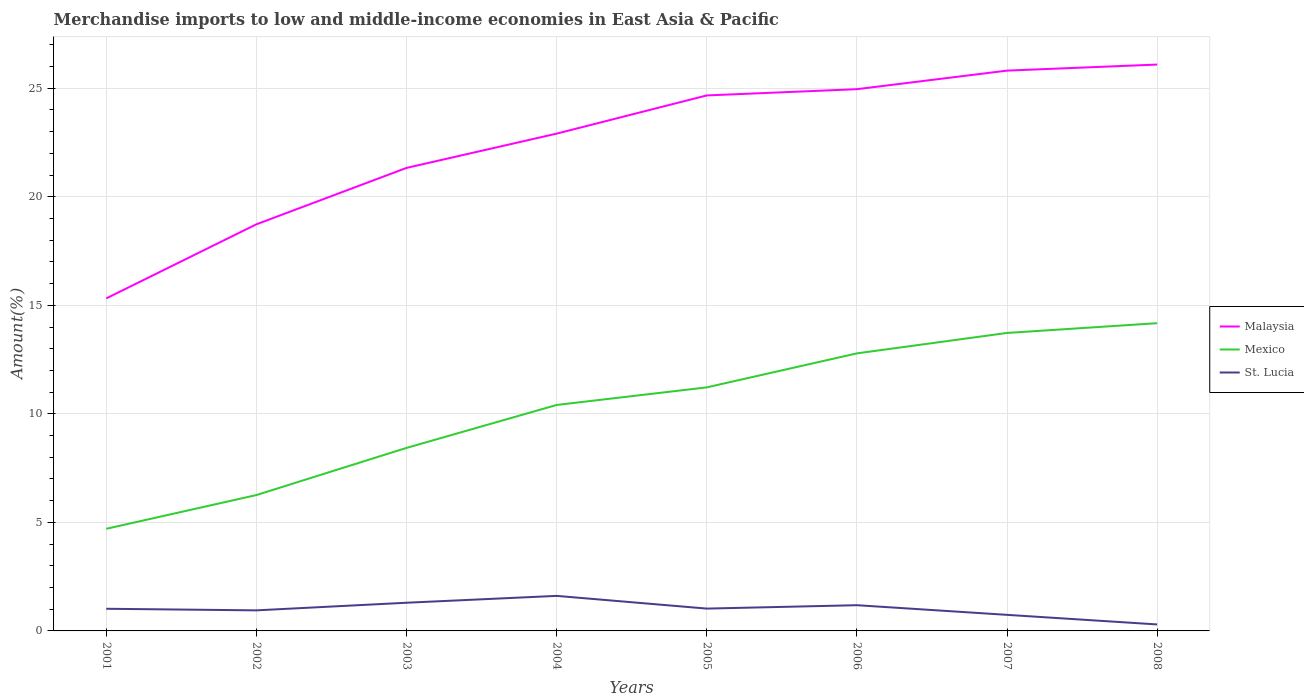How many different coloured lines are there?
Offer a very short reply. 3. Across all years, what is the maximum percentage of amount earned from merchandise imports in Mexico?
Ensure brevity in your answer.  4.71. In which year was the percentage of amount earned from merchandise imports in St. Lucia maximum?
Offer a terse response. 2008. What is the total percentage of amount earned from merchandise imports in Mexico in the graph?
Give a very brief answer. -3.73. What is the difference between the highest and the second highest percentage of amount earned from merchandise imports in St. Lucia?
Provide a succinct answer. 1.32. How many lines are there?
Offer a very short reply. 3. What is the difference between two consecutive major ticks on the Y-axis?
Your answer should be very brief. 5. Are the values on the major ticks of Y-axis written in scientific E-notation?
Give a very brief answer. No. Does the graph contain grids?
Make the answer very short. Yes. Where does the legend appear in the graph?
Make the answer very short. Center right. How many legend labels are there?
Ensure brevity in your answer.  3. How are the legend labels stacked?
Ensure brevity in your answer.  Vertical. What is the title of the graph?
Keep it short and to the point. Merchandise imports to low and middle-income economies in East Asia & Pacific. What is the label or title of the X-axis?
Provide a succinct answer. Years. What is the label or title of the Y-axis?
Provide a short and direct response. Amount(%). What is the Amount(%) of Malaysia in 2001?
Your answer should be compact. 15.32. What is the Amount(%) of Mexico in 2001?
Your response must be concise. 4.71. What is the Amount(%) of St. Lucia in 2001?
Your answer should be very brief. 1.02. What is the Amount(%) in Malaysia in 2002?
Your answer should be compact. 18.73. What is the Amount(%) in Mexico in 2002?
Provide a succinct answer. 6.26. What is the Amount(%) in St. Lucia in 2002?
Provide a succinct answer. 0.95. What is the Amount(%) of Malaysia in 2003?
Your response must be concise. 21.33. What is the Amount(%) in Mexico in 2003?
Ensure brevity in your answer.  8.43. What is the Amount(%) in St. Lucia in 2003?
Make the answer very short. 1.3. What is the Amount(%) of Malaysia in 2004?
Make the answer very short. 22.91. What is the Amount(%) in Mexico in 2004?
Your response must be concise. 10.41. What is the Amount(%) of St. Lucia in 2004?
Your response must be concise. 1.61. What is the Amount(%) of Malaysia in 2005?
Give a very brief answer. 24.67. What is the Amount(%) in Mexico in 2005?
Your answer should be compact. 11.22. What is the Amount(%) of St. Lucia in 2005?
Ensure brevity in your answer.  1.03. What is the Amount(%) in Malaysia in 2006?
Offer a very short reply. 24.96. What is the Amount(%) of Mexico in 2006?
Ensure brevity in your answer.  12.79. What is the Amount(%) of St. Lucia in 2006?
Provide a short and direct response. 1.18. What is the Amount(%) in Malaysia in 2007?
Your answer should be very brief. 25.81. What is the Amount(%) in Mexico in 2007?
Your response must be concise. 13.73. What is the Amount(%) in St. Lucia in 2007?
Keep it short and to the point. 0.74. What is the Amount(%) in Malaysia in 2008?
Your answer should be very brief. 26.09. What is the Amount(%) of Mexico in 2008?
Provide a succinct answer. 14.18. What is the Amount(%) of St. Lucia in 2008?
Keep it short and to the point. 0.3. Across all years, what is the maximum Amount(%) of Malaysia?
Give a very brief answer. 26.09. Across all years, what is the maximum Amount(%) of Mexico?
Ensure brevity in your answer.  14.18. Across all years, what is the maximum Amount(%) in St. Lucia?
Make the answer very short. 1.61. Across all years, what is the minimum Amount(%) of Malaysia?
Offer a terse response. 15.32. Across all years, what is the minimum Amount(%) of Mexico?
Offer a very short reply. 4.71. Across all years, what is the minimum Amount(%) in St. Lucia?
Offer a terse response. 0.3. What is the total Amount(%) in Malaysia in the graph?
Your answer should be compact. 179.83. What is the total Amount(%) in Mexico in the graph?
Your response must be concise. 81.72. What is the total Amount(%) of St. Lucia in the graph?
Give a very brief answer. 8.13. What is the difference between the Amount(%) of Malaysia in 2001 and that in 2002?
Make the answer very short. -3.41. What is the difference between the Amount(%) in Mexico in 2001 and that in 2002?
Provide a short and direct response. -1.55. What is the difference between the Amount(%) in St. Lucia in 2001 and that in 2002?
Provide a succinct answer. 0.07. What is the difference between the Amount(%) of Malaysia in 2001 and that in 2003?
Offer a very short reply. -6.01. What is the difference between the Amount(%) in Mexico in 2001 and that in 2003?
Keep it short and to the point. -3.73. What is the difference between the Amount(%) in St. Lucia in 2001 and that in 2003?
Your answer should be compact. -0.28. What is the difference between the Amount(%) in Malaysia in 2001 and that in 2004?
Your answer should be compact. -7.59. What is the difference between the Amount(%) of Mexico in 2001 and that in 2004?
Keep it short and to the point. -5.7. What is the difference between the Amount(%) of St. Lucia in 2001 and that in 2004?
Provide a succinct answer. -0.59. What is the difference between the Amount(%) of Malaysia in 2001 and that in 2005?
Keep it short and to the point. -9.35. What is the difference between the Amount(%) in Mexico in 2001 and that in 2005?
Ensure brevity in your answer.  -6.51. What is the difference between the Amount(%) in St. Lucia in 2001 and that in 2005?
Make the answer very short. -0.01. What is the difference between the Amount(%) of Malaysia in 2001 and that in 2006?
Give a very brief answer. -9.64. What is the difference between the Amount(%) in Mexico in 2001 and that in 2006?
Make the answer very short. -8.08. What is the difference between the Amount(%) in St. Lucia in 2001 and that in 2006?
Keep it short and to the point. -0.16. What is the difference between the Amount(%) of Malaysia in 2001 and that in 2007?
Provide a short and direct response. -10.49. What is the difference between the Amount(%) of Mexico in 2001 and that in 2007?
Offer a very short reply. -9.02. What is the difference between the Amount(%) in St. Lucia in 2001 and that in 2007?
Provide a succinct answer. 0.28. What is the difference between the Amount(%) in Malaysia in 2001 and that in 2008?
Your answer should be compact. -10.77. What is the difference between the Amount(%) of Mexico in 2001 and that in 2008?
Give a very brief answer. -9.47. What is the difference between the Amount(%) in St. Lucia in 2001 and that in 2008?
Keep it short and to the point. 0.72. What is the difference between the Amount(%) in Malaysia in 2002 and that in 2003?
Keep it short and to the point. -2.6. What is the difference between the Amount(%) of Mexico in 2002 and that in 2003?
Offer a terse response. -2.17. What is the difference between the Amount(%) in St. Lucia in 2002 and that in 2003?
Provide a short and direct response. -0.35. What is the difference between the Amount(%) of Malaysia in 2002 and that in 2004?
Offer a terse response. -4.18. What is the difference between the Amount(%) in Mexico in 2002 and that in 2004?
Your answer should be compact. -4.15. What is the difference between the Amount(%) of St. Lucia in 2002 and that in 2004?
Your answer should be compact. -0.67. What is the difference between the Amount(%) of Malaysia in 2002 and that in 2005?
Offer a terse response. -5.94. What is the difference between the Amount(%) in Mexico in 2002 and that in 2005?
Your response must be concise. -4.96. What is the difference between the Amount(%) in St. Lucia in 2002 and that in 2005?
Offer a terse response. -0.08. What is the difference between the Amount(%) of Malaysia in 2002 and that in 2006?
Your answer should be compact. -6.23. What is the difference between the Amount(%) of Mexico in 2002 and that in 2006?
Your answer should be compact. -6.53. What is the difference between the Amount(%) of St. Lucia in 2002 and that in 2006?
Keep it short and to the point. -0.24. What is the difference between the Amount(%) in Malaysia in 2002 and that in 2007?
Provide a succinct answer. -7.08. What is the difference between the Amount(%) in Mexico in 2002 and that in 2007?
Give a very brief answer. -7.47. What is the difference between the Amount(%) in St. Lucia in 2002 and that in 2007?
Provide a short and direct response. 0.21. What is the difference between the Amount(%) of Malaysia in 2002 and that in 2008?
Your answer should be compact. -7.36. What is the difference between the Amount(%) of Mexico in 2002 and that in 2008?
Keep it short and to the point. -7.92. What is the difference between the Amount(%) in St. Lucia in 2002 and that in 2008?
Keep it short and to the point. 0.65. What is the difference between the Amount(%) in Malaysia in 2003 and that in 2004?
Provide a succinct answer. -1.58. What is the difference between the Amount(%) in Mexico in 2003 and that in 2004?
Your answer should be very brief. -1.98. What is the difference between the Amount(%) of St. Lucia in 2003 and that in 2004?
Your answer should be compact. -0.32. What is the difference between the Amount(%) in Malaysia in 2003 and that in 2005?
Provide a succinct answer. -3.34. What is the difference between the Amount(%) of Mexico in 2003 and that in 2005?
Give a very brief answer. -2.79. What is the difference between the Amount(%) in St. Lucia in 2003 and that in 2005?
Offer a terse response. 0.27. What is the difference between the Amount(%) of Malaysia in 2003 and that in 2006?
Ensure brevity in your answer.  -3.63. What is the difference between the Amount(%) in Mexico in 2003 and that in 2006?
Your answer should be very brief. -4.35. What is the difference between the Amount(%) in St. Lucia in 2003 and that in 2006?
Ensure brevity in your answer.  0.11. What is the difference between the Amount(%) of Malaysia in 2003 and that in 2007?
Your response must be concise. -4.48. What is the difference between the Amount(%) in Mexico in 2003 and that in 2007?
Provide a short and direct response. -5.3. What is the difference between the Amount(%) in St. Lucia in 2003 and that in 2007?
Your response must be concise. 0.56. What is the difference between the Amount(%) of Malaysia in 2003 and that in 2008?
Provide a succinct answer. -4.76. What is the difference between the Amount(%) of Mexico in 2003 and that in 2008?
Your answer should be compact. -5.75. What is the difference between the Amount(%) of St. Lucia in 2003 and that in 2008?
Your answer should be very brief. 1. What is the difference between the Amount(%) of Malaysia in 2004 and that in 2005?
Keep it short and to the point. -1.76. What is the difference between the Amount(%) in Mexico in 2004 and that in 2005?
Make the answer very short. -0.81. What is the difference between the Amount(%) in St. Lucia in 2004 and that in 2005?
Offer a terse response. 0.59. What is the difference between the Amount(%) in Malaysia in 2004 and that in 2006?
Give a very brief answer. -2.05. What is the difference between the Amount(%) of Mexico in 2004 and that in 2006?
Offer a terse response. -2.38. What is the difference between the Amount(%) of St. Lucia in 2004 and that in 2006?
Keep it short and to the point. 0.43. What is the difference between the Amount(%) of Malaysia in 2004 and that in 2007?
Make the answer very short. -2.9. What is the difference between the Amount(%) in Mexico in 2004 and that in 2007?
Keep it short and to the point. -3.32. What is the difference between the Amount(%) of St. Lucia in 2004 and that in 2007?
Your answer should be very brief. 0.87. What is the difference between the Amount(%) of Malaysia in 2004 and that in 2008?
Make the answer very short. -3.18. What is the difference between the Amount(%) of Mexico in 2004 and that in 2008?
Offer a very short reply. -3.77. What is the difference between the Amount(%) of St. Lucia in 2004 and that in 2008?
Make the answer very short. 1.32. What is the difference between the Amount(%) of Malaysia in 2005 and that in 2006?
Your answer should be very brief. -0.29. What is the difference between the Amount(%) in Mexico in 2005 and that in 2006?
Ensure brevity in your answer.  -1.57. What is the difference between the Amount(%) of St. Lucia in 2005 and that in 2006?
Your response must be concise. -0.16. What is the difference between the Amount(%) of Malaysia in 2005 and that in 2007?
Offer a terse response. -1.14. What is the difference between the Amount(%) in Mexico in 2005 and that in 2007?
Offer a terse response. -2.51. What is the difference between the Amount(%) of St. Lucia in 2005 and that in 2007?
Make the answer very short. 0.29. What is the difference between the Amount(%) of Malaysia in 2005 and that in 2008?
Ensure brevity in your answer.  -1.42. What is the difference between the Amount(%) in Mexico in 2005 and that in 2008?
Make the answer very short. -2.96. What is the difference between the Amount(%) in St. Lucia in 2005 and that in 2008?
Your answer should be very brief. 0.73. What is the difference between the Amount(%) in Malaysia in 2006 and that in 2007?
Offer a terse response. -0.86. What is the difference between the Amount(%) in Mexico in 2006 and that in 2007?
Offer a terse response. -0.94. What is the difference between the Amount(%) of St. Lucia in 2006 and that in 2007?
Make the answer very short. 0.44. What is the difference between the Amount(%) of Malaysia in 2006 and that in 2008?
Your answer should be compact. -1.13. What is the difference between the Amount(%) in Mexico in 2006 and that in 2008?
Offer a terse response. -1.39. What is the difference between the Amount(%) in St. Lucia in 2006 and that in 2008?
Ensure brevity in your answer.  0.89. What is the difference between the Amount(%) in Malaysia in 2007 and that in 2008?
Give a very brief answer. -0.28. What is the difference between the Amount(%) in Mexico in 2007 and that in 2008?
Your response must be concise. -0.45. What is the difference between the Amount(%) in St. Lucia in 2007 and that in 2008?
Offer a very short reply. 0.44. What is the difference between the Amount(%) of Malaysia in 2001 and the Amount(%) of Mexico in 2002?
Give a very brief answer. 9.06. What is the difference between the Amount(%) in Malaysia in 2001 and the Amount(%) in St. Lucia in 2002?
Keep it short and to the point. 14.37. What is the difference between the Amount(%) in Mexico in 2001 and the Amount(%) in St. Lucia in 2002?
Provide a short and direct response. 3.76. What is the difference between the Amount(%) of Malaysia in 2001 and the Amount(%) of Mexico in 2003?
Your response must be concise. 6.89. What is the difference between the Amount(%) of Malaysia in 2001 and the Amount(%) of St. Lucia in 2003?
Give a very brief answer. 14.02. What is the difference between the Amount(%) in Mexico in 2001 and the Amount(%) in St. Lucia in 2003?
Provide a short and direct response. 3.41. What is the difference between the Amount(%) in Malaysia in 2001 and the Amount(%) in Mexico in 2004?
Provide a succinct answer. 4.91. What is the difference between the Amount(%) of Malaysia in 2001 and the Amount(%) of St. Lucia in 2004?
Ensure brevity in your answer.  13.71. What is the difference between the Amount(%) of Mexico in 2001 and the Amount(%) of St. Lucia in 2004?
Ensure brevity in your answer.  3.09. What is the difference between the Amount(%) of Malaysia in 2001 and the Amount(%) of Mexico in 2005?
Provide a succinct answer. 4.1. What is the difference between the Amount(%) of Malaysia in 2001 and the Amount(%) of St. Lucia in 2005?
Provide a succinct answer. 14.29. What is the difference between the Amount(%) in Mexico in 2001 and the Amount(%) in St. Lucia in 2005?
Your answer should be very brief. 3.68. What is the difference between the Amount(%) of Malaysia in 2001 and the Amount(%) of Mexico in 2006?
Keep it short and to the point. 2.53. What is the difference between the Amount(%) in Malaysia in 2001 and the Amount(%) in St. Lucia in 2006?
Provide a short and direct response. 14.14. What is the difference between the Amount(%) of Mexico in 2001 and the Amount(%) of St. Lucia in 2006?
Make the answer very short. 3.52. What is the difference between the Amount(%) of Malaysia in 2001 and the Amount(%) of Mexico in 2007?
Your response must be concise. 1.59. What is the difference between the Amount(%) in Malaysia in 2001 and the Amount(%) in St. Lucia in 2007?
Offer a very short reply. 14.58. What is the difference between the Amount(%) in Mexico in 2001 and the Amount(%) in St. Lucia in 2007?
Provide a short and direct response. 3.97. What is the difference between the Amount(%) of Malaysia in 2001 and the Amount(%) of Mexico in 2008?
Make the answer very short. 1.14. What is the difference between the Amount(%) in Malaysia in 2001 and the Amount(%) in St. Lucia in 2008?
Your answer should be very brief. 15.02. What is the difference between the Amount(%) of Mexico in 2001 and the Amount(%) of St. Lucia in 2008?
Offer a very short reply. 4.41. What is the difference between the Amount(%) in Malaysia in 2002 and the Amount(%) in Mexico in 2003?
Your answer should be compact. 10.3. What is the difference between the Amount(%) of Malaysia in 2002 and the Amount(%) of St. Lucia in 2003?
Your response must be concise. 17.43. What is the difference between the Amount(%) of Mexico in 2002 and the Amount(%) of St. Lucia in 2003?
Give a very brief answer. 4.96. What is the difference between the Amount(%) in Malaysia in 2002 and the Amount(%) in Mexico in 2004?
Ensure brevity in your answer.  8.32. What is the difference between the Amount(%) of Malaysia in 2002 and the Amount(%) of St. Lucia in 2004?
Ensure brevity in your answer.  17.12. What is the difference between the Amount(%) of Mexico in 2002 and the Amount(%) of St. Lucia in 2004?
Your answer should be very brief. 4.64. What is the difference between the Amount(%) in Malaysia in 2002 and the Amount(%) in Mexico in 2005?
Your response must be concise. 7.51. What is the difference between the Amount(%) of Malaysia in 2002 and the Amount(%) of St. Lucia in 2005?
Your answer should be compact. 17.7. What is the difference between the Amount(%) in Mexico in 2002 and the Amount(%) in St. Lucia in 2005?
Offer a terse response. 5.23. What is the difference between the Amount(%) of Malaysia in 2002 and the Amount(%) of Mexico in 2006?
Provide a succinct answer. 5.95. What is the difference between the Amount(%) of Malaysia in 2002 and the Amount(%) of St. Lucia in 2006?
Make the answer very short. 17.55. What is the difference between the Amount(%) of Mexico in 2002 and the Amount(%) of St. Lucia in 2006?
Keep it short and to the point. 5.07. What is the difference between the Amount(%) in Malaysia in 2002 and the Amount(%) in Mexico in 2007?
Your answer should be very brief. 5. What is the difference between the Amount(%) of Malaysia in 2002 and the Amount(%) of St. Lucia in 2007?
Provide a succinct answer. 17.99. What is the difference between the Amount(%) of Mexico in 2002 and the Amount(%) of St. Lucia in 2007?
Your answer should be very brief. 5.52. What is the difference between the Amount(%) of Malaysia in 2002 and the Amount(%) of Mexico in 2008?
Make the answer very short. 4.56. What is the difference between the Amount(%) in Malaysia in 2002 and the Amount(%) in St. Lucia in 2008?
Ensure brevity in your answer.  18.43. What is the difference between the Amount(%) in Mexico in 2002 and the Amount(%) in St. Lucia in 2008?
Ensure brevity in your answer.  5.96. What is the difference between the Amount(%) in Malaysia in 2003 and the Amount(%) in Mexico in 2004?
Provide a succinct answer. 10.92. What is the difference between the Amount(%) of Malaysia in 2003 and the Amount(%) of St. Lucia in 2004?
Provide a succinct answer. 19.72. What is the difference between the Amount(%) in Mexico in 2003 and the Amount(%) in St. Lucia in 2004?
Your answer should be compact. 6.82. What is the difference between the Amount(%) in Malaysia in 2003 and the Amount(%) in Mexico in 2005?
Offer a terse response. 10.11. What is the difference between the Amount(%) of Malaysia in 2003 and the Amount(%) of St. Lucia in 2005?
Ensure brevity in your answer.  20.3. What is the difference between the Amount(%) in Mexico in 2003 and the Amount(%) in St. Lucia in 2005?
Offer a terse response. 7.4. What is the difference between the Amount(%) of Malaysia in 2003 and the Amount(%) of Mexico in 2006?
Provide a succinct answer. 8.54. What is the difference between the Amount(%) of Malaysia in 2003 and the Amount(%) of St. Lucia in 2006?
Provide a succinct answer. 20.15. What is the difference between the Amount(%) in Mexico in 2003 and the Amount(%) in St. Lucia in 2006?
Offer a terse response. 7.25. What is the difference between the Amount(%) of Malaysia in 2003 and the Amount(%) of Mexico in 2007?
Provide a short and direct response. 7.6. What is the difference between the Amount(%) of Malaysia in 2003 and the Amount(%) of St. Lucia in 2007?
Provide a short and direct response. 20.59. What is the difference between the Amount(%) of Mexico in 2003 and the Amount(%) of St. Lucia in 2007?
Your answer should be compact. 7.69. What is the difference between the Amount(%) of Malaysia in 2003 and the Amount(%) of Mexico in 2008?
Offer a terse response. 7.15. What is the difference between the Amount(%) of Malaysia in 2003 and the Amount(%) of St. Lucia in 2008?
Provide a succinct answer. 21.03. What is the difference between the Amount(%) of Mexico in 2003 and the Amount(%) of St. Lucia in 2008?
Your answer should be compact. 8.13. What is the difference between the Amount(%) of Malaysia in 2004 and the Amount(%) of Mexico in 2005?
Ensure brevity in your answer.  11.69. What is the difference between the Amount(%) of Malaysia in 2004 and the Amount(%) of St. Lucia in 2005?
Provide a short and direct response. 21.88. What is the difference between the Amount(%) of Mexico in 2004 and the Amount(%) of St. Lucia in 2005?
Provide a short and direct response. 9.38. What is the difference between the Amount(%) in Malaysia in 2004 and the Amount(%) in Mexico in 2006?
Provide a short and direct response. 10.12. What is the difference between the Amount(%) in Malaysia in 2004 and the Amount(%) in St. Lucia in 2006?
Provide a succinct answer. 21.73. What is the difference between the Amount(%) of Mexico in 2004 and the Amount(%) of St. Lucia in 2006?
Provide a succinct answer. 9.23. What is the difference between the Amount(%) of Malaysia in 2004 and the Amount(%) of Mexico in 2007?
Offer a very short reply. 9.18. What is the difference between the Amount(%) of Malaysia in 2004 and the Amount(%) of St. Lucia in 2007?
Ensure brevity in your answer.  22.17. What is the difference between the Amount(%) of Mexico in 2004 and the Amount(%) of St. Lucia in 2007?
Give a very brief answer. 9.67. What is the difference between the Amount(%) in Malaysia in 2004 and the Amount(%) in Mexico in 2008?
Your answer should be compact. 8.73. What is the difference between the Amount(%) in Malaysia in 2004 and the Amount(%) in St. Lucia in 2008?
Offer a very short reply. 22.61. What is the difference between the Amount(%) in Mexico in 2004 and the Amount(%) in St. Lucia in 2008?
Your answer should be compact. 10.11. What is the difference between the Amount(%) of Malaysia in 2005 and the Amount(%) of Mexico in 2006?
Offer a very short reply. 11.88. What is the difference between the Amount(%) in Malaysia in 2005 and the Amount(%) in St. Lucia in 2006?
Your answer should be compact. 23.49. What is the difference between the Amount(%) of Mexico in 2005 and the Amount(%) of St. Lucia in 2006?
Offer a terse response. 10.04. What is the difference between the Amount(%) of Malaysia in 2005 and the Amount(%) of Mexico in 2007?
Offer a terse response. 10.94. What is the difference between the Amount(%) of Malaysia in 2005 and the Amount(%) of St. Lucia in 2007?
Your answer should be compact. 23.93. What is the difference between the Amount(%) in Mexico in 2005 and the Amount(%) in St. Lucia in 2007?
Make the answer very short. 10.48. What is the difference between the Amount(%) of Malaysia in 2005 and the Amount(%) of Mexico in 2008?
Give a very brief answer. 10.49. What is the difference between the Amount(%) of Malaysia in 2005 and the Amount(%) of St. Lucia in 2008?
Give a very brief answer. 24.37. What is the difference between the Amount(%) of Mexico in 2005 and the Amount(%) of St. Lucia in 2008?
Provide a succinct answer. 10.92. What is the difference between the Amount(%) in Malaysia in 2006 and the Amount(%) in Mexico in 2007?
Give a very brief answer. 11.23. What is the difference between the Amount(%) in Malaysia in 2006 and the Amount(%) in St. Lucia in 2007?
Provide a succinct answer. 24.22. What is the difference between the Amount(%) in Mexico in 2006 and the Amount(%) in St. Lucia in 2007?
Your answer should be very brief. 12.05. What is the difference between the Amount(%) of Malaysia in 2006 and the Amount(%) of Mexico in 2008?
Offer a terse response. 10.78. What is the difference between the Amount(%) in Malaysia in 2006 and the Amount(%) in St. Lucia in 2008?
Your response must be concise. 24.66. What is the difference between the Amount(%) of Mexico in 2006 and the Amount(%) of St. Lucia in 2008?
Keep it short and to the point. 12.49. What is the difference between the Amount(%) of Malaysia in 2007 and the Amount(%) of Mexico in 2008?
Your answer should be compact. 11.64. What is the difference between the Amount(%) in Malaysia in 2007 and the Amount(%) in St. Lucia in 2008?
Offer a very short reply. 25.51. What is the difference between the Amount(%) in Mexico in 2007 and the Amount(%) in St. Lucia in 2008?
Give a very brief answer. 13.43. What is the average Amount(%) in Malaysia per year?
Provide a short and direct response. 22.48. What is the average Amount(%) in Mexico per year?
Give a very brief answer. 10.21. What is the average Amount(%) of St. Lucia per year?
Your response must be concise. 1.02. In the year 2001, what is the difference between the Amount(%) of Malaysia and Amount(%) of Mexico?
Give a very brief answer. 10.61. In the year 2001, what is the difference between the Amount(%) in Malaysia and Amount(%) in St. Lucia?
Your answer should be very brief. 14.3. In the year 2001, what is the difference between the Amount(%) of Mexico and Amount(%) of St. Lucia?
Keep it short and to the point. 3.68. In the year 2002, what is the difference between the Amount(%) of Malaysia and Amount(%) of Mexico?
Keep it short and to the point. 12.47. In the year 2002, what is the difference between the Amount(%) in Malaysia and Amount(%) in St. Lucia?
Provide a succinct answer. 17.79. In the year 2002, what is the difference between the Amount(%) of Mexico and Amount(%) of St. Lucia?
Your answer should be compact. 5.31. In the year 2003, what is the difference between the Amount(%) in Malaysia and Amount(%) in Mexico?
Offer a very short reply. 12.9. In the year 2003, what is the difference between the Amount(%) in Malaysia and Amount(%) in St. Lucia?
Give a very brief answer. 20.03. In the year 2003, what is the difference between the Amount(%) in Mexico and Amount(%) in St. Lucia?
Your answer should be compact. 7.13. In the year 2004, what is the difference between the Amount(%) of Malaysia and Amount(%) of Mexico?
Offer a very short reply. 12.5. In the year 2004, what is the difference between the Amount(%) in Malaysia and Amount(%) in St. Lucia?
Offer a very short reply. 21.3. In the year 2004, what is the difference between the Amount(%) in Mexico and Amount(%) in St. Lucia?
Provide a short and direct response. 8.8. In the year 2005, what is the difference between the Amount(%) in Malaysia and Amount(%) in Mexico?
Ensure brevity in your answer.  13.45. In the year 2005, what is the difference between the Amount(%) of Malaysia and Amount(%) of St. Lucia?
Ensure brevity in your answer.  23.64. In the year 2005, what is the difference between the Amount(%) in Mexico and Amount(%) in St. Lucia?
Make the answer very short. 10.19. In the year 2006, what is the difference between the Amount(%) in Malaysia and Amount(%) in Mexico?
Give a very brief answer. 12.17. In the year 2006, what is the difference between the Amount(%) in Malaysia and Amount(%) in St. Lucia?
Make the answer very short. 23.77. In the year 2006, what is the difference between the Amount(%) in Mexico and Amount(%) in St. Lucia?
Your answer should be very brief. 11.6. In the year 2007, what is the difference between the Amount(%) in Malaysia and Amount(%) in Mexico?
Offer a very short reply. 12.09. In the year 2007, what is the difference between the Amount(%) in Malaysia and Amount(%) in St. Lucia?
Provide a succinct answer. 25.07. In the year 2007, what is the difference between the Amount(%) of Mexico and Amount(%) of St. Lucia?
Keep it short and to the point. 12.99. In the year 2008, what is the difference between the Amount(%) in Malaysia and Amount(%) in Mexico?
Ensure brevity in your answer.  11.91. In the year 2008, what is the difference between the Amount(%) in Malaysia and Amount(%) in St. Lucia?
Ensure brevity in your answer.  25.79. In the year 2008, what is the difference between the Amount(%) of Mexico and Amount(%) of St. Lucia?
Offer a very short reply. 13.88. What is the ratio of the Amount(%) of Malaysia in 2001 to that in 2002?
Offer a terse response. 0.82. What is the ratio of the Amount(%) in Mexico in 2001 to that in 2002?
Give a very brief answer. 0.75. What is the ratio of the Amount(%) of St. Lucia in 2001 to that in 2002?
Make the answer very short. 1.08. What is the ratio of the Amount(%) of Malaysia in 2001 to that in 2003?
Your response must be concise. 0.72. What is the ratio of the Amount(%) in Mexico in 2001 to that in 2003?
Keep it short and to the point. 0.56. What is the ratio of the Amount(%) in St. Lucia in 2001 to that in 2003?
Make the answer very short. 0.79. What is the ratio of the Amount(%) of Malaysia in 2001 to that in 2004?
Provide a short and direct response. 0.67. What is the ratio of the Amount(%) of Mexico in 2001 to that in 2004?
Ensure brevity in your answer.  0.45. What is the ratio of the Amount(%) in St. Lucia in 2001 to that in 2004?
Provide a succinct answer. 0.63. What is the ratio of the Amount(%) in Malaysia in 2001 to that in 2005?
Provide a short and direct response. 0.62. What is the ratio of the Amount(%) of Mexico in 2001 to that in 2005?
Provide a succinct answer. 0.42. What is the ratio of the Amount(%) in St. Lucia in 2001 to that in 2005?
Keep it short and to the point. 0.99. What is the ratio of the Amount(%) of Malaysia in 2001 to that in 2006?
Your answer should be very brief. 0.61. What is the ratio of the Amount(%) of Mexico in 2001 to that in 2006?
Keep it short and to the point. 0.37. What is the ratio of the Amount(%) of St. Lucia in 2001 to that in 2006?
Offer a very short reply. 0.86. What is the ratio of the Amount(%) of Malaysia in 2001 to that in 2007?
Your answer should be very brief. 0.59. What is the ratio of the Amount(%) in Mexico in 2001 to that in 2007?
Give a very brief answer. 0.34. What is the ratio of the Amount(%) in St. Lucia in 2001 to that in 2007?
Offer a very short reply. 1.38. What is the ratio of the Amount(%) of Malaysia in 2001 to that in 2008?
Your answer should be compact. 0.59. What is the ratio of the Amount(%) in Mexico in 2001 to that in 2008?
Make the answer very short. 0.33. What is the ratio of the Amount(%) of St. Lucia in 2001 to that in 2008?
Provide a short and direct response. 3.41. What is the ratio of the Amount(%) of Malaysia in 2002 to that in 2003?
Make the answer very short. 0.88. What is the ratio of the Amount(%) of Mexico in 2002 to that in 2003?
Your answer should be very brief. 0.74. What is the ratio of the Amount(%) of St. Lucia in 2002 to that in 2003?
Ensure brevity in your answer.  0.73. What is the ratio of the Amount(%) of Malaysia in 2002 to that in 2004?
Offer a very short reply. 0.82. What is the ratio of the Amount(%) in Mexico in 2002 to that in 2004?
Your answer should be very brief. 0.6. What is the ratio of the Amount(%) of St. Lucia in 2002 to that in 2004?
Provide a short and direct response. 0.59. What is the ratio of the Amount(%) in Malaysia in 2002 to that in 2005?
Make the answer very short. 0.76. What is the ratio of the Amount(%) in Mexico in 2002 to that in 2005?
Keep it short and to the point. 0.56. What is the ratio of the Amount(%) of St. Lucia in 2002 to that in 2005?
Keep it short and to the point. 0.92. What is the ratio of the Amount(%) in Malaysia in 2002 to that in 2006?
Make the answer very short. 0.75. What is the ratio of the Amount(%) of Mexico in 2002 to that in 2006?
Keep it short and to the point. 0.49. What is the ratio of the Amount(%) of St. Lucia in 2002 to that in 2006?
Ensure brevity in your answer.  0.8. What is the ratio of the Amount(%) in Malaysia in 2002 to that in 2007?
Your response must be concise. 0.73. What is the ratio of the Amount(%) in Mexico in 2002 to that in 2007?
Your answer should be compact. 0.46. What is the ratio of the Amount(%) in St. Lucia in 2002 to that in 2007?
Your answer should be very brief. 1.28. What is the ratio of the Amount(%) of Malaysia in 2002 to that in 2008?
Give a very brief answer. 0.72. What is the ratio of the Amount(%) of Mexico in 2002 to that in 2008?
Provide a short and direct response. 0.44. What is the ratio of the Amount(%) of St. Lucia in 2002 to that in 2008?
Your answer should be compact. 3.17. What is the ratio of the Amount(%) in Mexico in 2003 to that in 2004?
Keep it short and to the point. 0.81. What is the ratio of the Amount(%) of St. Lucia in 2003 to that in 2004?
Your answer should be compact. 0.8. What is the ratio of the Amount(%) in Malaysia in 2003 to that in 2005?
Ensure brevity in your answer.  0.86. What is the ratio of the Amount(%) in Mexico in 2003 to that in 2005?
Provide a short and direct response. 0.75. What is the ratio of the Amount(%) in St. Lucia in 2003 to that in 2005?
Your answer should be very brief. 1.26. What is the ratio of the Amount(%) of Malaysia in 2003 to that in 2006?
Keep it short and to the point. 0.85. What is the ratio of the Amount(%) in Mexico in 2003 to that in 2006?
Your answer should be compact. 0.66. What is the ratio of the Amount(%) in St. Lucia in 2003 to that in 2006?
Offer a terse response. 1.1. What is the ratio of the Amount(%) in Malaysia in 2003 to that in 2007?
Make the answer very short. 0.83. What is the ratio of the Amount(%) of Mexico in 2003 to that in 2007?
Your response must be concise. 0.61. What is the ratio of the Amount(%) in St. Lucia in 2003 to that in 2007?
Keep it short and to the point. 1.75. What is the ratio of the Amount(%) in Malaysia in 2003 to that in 2008?
Give a very brief answer. 0.82. What is the ratio of the Amount(%) in Mexico in 2003 to that in 2008?
Make the answer very short. 0.59. What is the ratio of the Amount(%) in St. Lucia in 2003 to that in 2008?
Your answer should be compact. 4.34. What is the ratio of the Amount(%) of Malaysia in 2004 to that in 2005?
Offer a very short reply. 0.93. What is the ratio of the Amount(%) in Mexico in 2004 to that in 2005?
Your answer should be very brief. 0.93. What is the ratio of the Amount(%) of St. Lucia in 2004 to that in 2005?
Give a very brief answer. 1.57. What is the ratio of the Amount(%) in Malaysia in 2004 to that in 2006?
Keep it short and to the point. 0.92. What is the ratio of the Amount(%) of Mexico in 2004 to that in 2006?
Give a very brief answer. 0.81. What is the ratio of the Amount(%) of St. Lucia in 2004 to that in 2006?
Offer a terse response. 1.36. What is the ratio of the Amount(%) in Malaysia in 2004 to that in 2007?
Make the answer very short. 0.89. What is the ratio of the Amount(%) in Mexico in 2004 to that in 2007?
Offer a very short reply. 0.76. What is the ratio of the Amount(%) of St. Lucia in 2004 to that in 2007?
Keep it short and to the point. 2.18. What is the ratio of the Amount(%) in Malaysia in 2004 to that in 2008?
Keep it short and to the point. 0.88. What is the ratio of the Amount(%) in Mexico in 2004 to that in 2008?
Give a very brief answer. 0.73. What is the ratio of the Amount(%) in St. Lucia in 2004 to that in 2008?
Your response must be concise. 5.4. What is the ratio of the Amount(%) of Malaysia in 2005 to that in 2006?
Offer a very short reply. 0.99. What is the ratio of the Amount(%) in Mexico in 2005 to that in 2006?
Your response must be concise. 0.88. What is the ratio of the Amount(%) of St. Lucia in 2005 to that in 2006?
Keep it short and to the point. 0.87. What is the ratio of the Amount(%) in Malaysia in 2005 to that in 2007?
Your answer should be very brief. 0.96. What is the ratio of the Amount(%) of Mexico in 2005 to that in 2007?
Give a very brief answer. 0.82. What is the ratio of the Amount(%) in St. Lucia in 2005 to that in 2007?
Offer a terse response. 1.39. What is the ratio of the Amount(%) in Malaysia in 2005 to that in 2008?
Offer a very short reply. 0.95. What is the ratio of the Amount(%) of Mexico in 2005 to that in 2008?
Give a very brief answer. 0.79. What is the ratio of the Amount(%) in St. Lucia in 2005 to that in 2008?
Make the answer very short. 3.44. What is the ratio of the Amount(%) of Malaysia in 2006 to that in 2007?
Your answer should be compact. 0.97. What is the ratio of the Amount(%) in Mexico in 2006 to that in 2007?
Give a very brief answer. 0.93. What is the ratio of the Amount(%) of St. Lucia in 2006 to that in 2007?
Offer a very short reply. 1.6. What is the ratio of the Amount(%) in Malaysia in 2006 to that in 2008?
Give a very brief answer. 0.96. What is the ratio of the Amount(%) of Mexico in 2006 to that in 2008?
Offer a terse response. 0.9. What is the ratio of the Amount(%) of St. Lucia in 2006 to that in 2008?
Keep it short and to the point. 3.96. What is the ratio of the Amount(%) of Malaysia in 2007 to that in 2008?
Ensure brevity in your answer.  0.99. What is the ratio of the Amount(%) of Mexico in 2007 to that in 2008?
Your response must be concise. 0.97. What is the ratio of the Amount(%) of St. Lucia in 2007 to that in 2008?
Your answer should be compact. 2.48. What is the difference between the highest and the second highest Amount(%) in Malaysia?
Provide a succinct answer. 0.28. What is the difference between the highest and the second highest Amount(%) in Mexico?
Your answer should be compact. 0.45. What is the difference between the highest and the second highest Amount(%) of St. Lucia?
Keep it short and to the point. 0.32. What is the difference between the highest and the lowest Amount(%) of Malaysia?
Your answer should be compact. 10.77. What is the difference between the highest and the lowest Amount(%) of Mexico?
Keep it short and to the point. 9.47. What is the difference between the highest and the lowest Amount(%) in St. Lucia?
Your answer should be very brief. 1.32. 